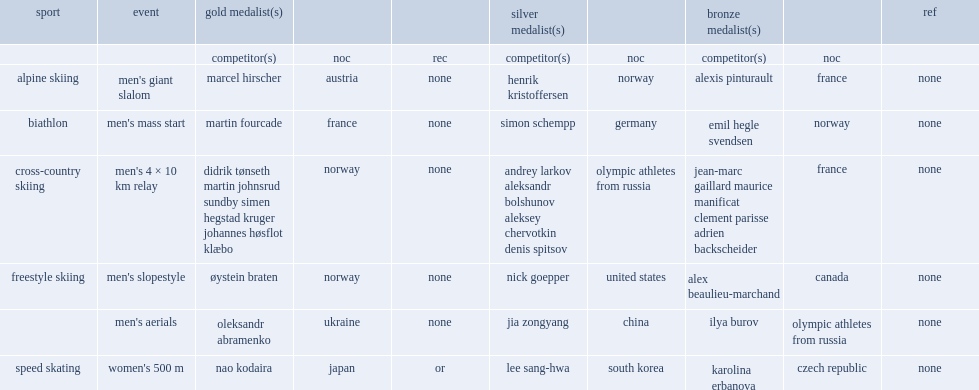Who won the men's aerials freestyle skiing olympic silver medal? Jia zongyang. 